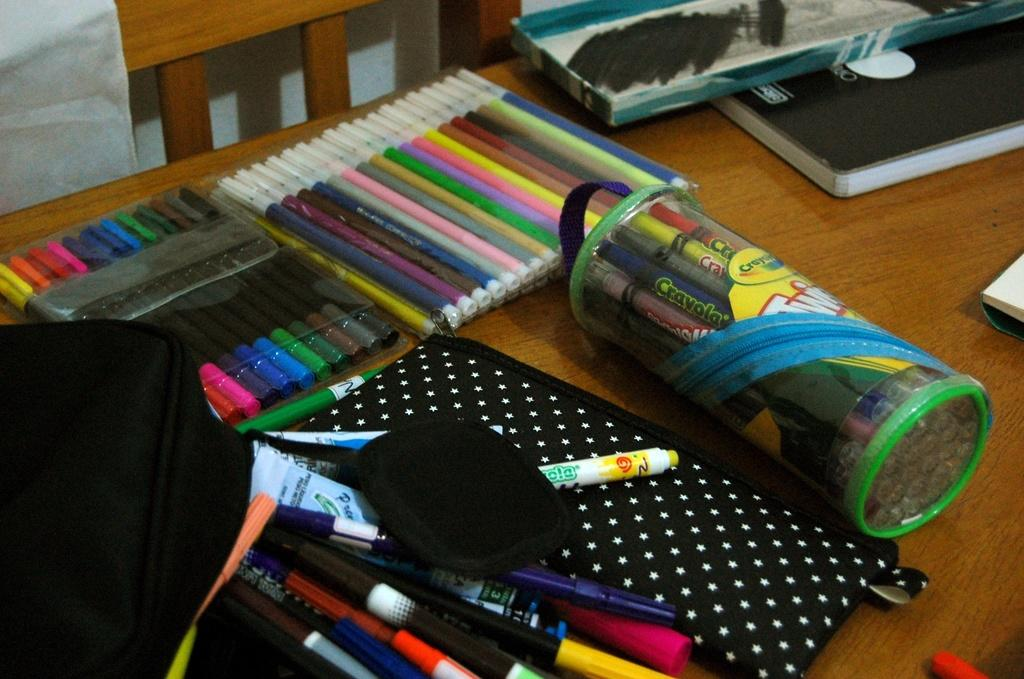What writing instruments are visible in the image? There are sketch pens and pens in the image. What might be used to store or carry items in the image? There are pouches in the image. Can you describe the background of the image? There is a wooden chair, a table, and other objects in the background of the image. What type of flesh can be seen in the image? There is no flesh present in the image; it features writing instruments, pouches, and objects in the background. 